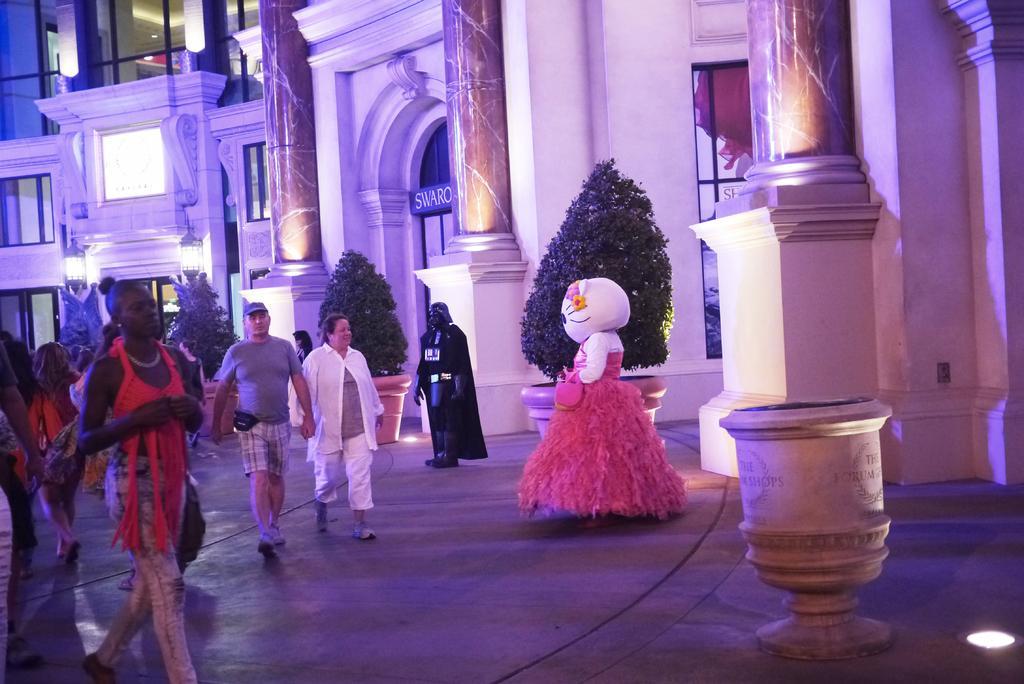How would you summarize this image in a sentence or two? On the left there are few persons walking on the road and there are mascots. In the background there is a building,glass doors,poles,lights,pillars,house plants in pots,poster on the wall and lights on the floor. 